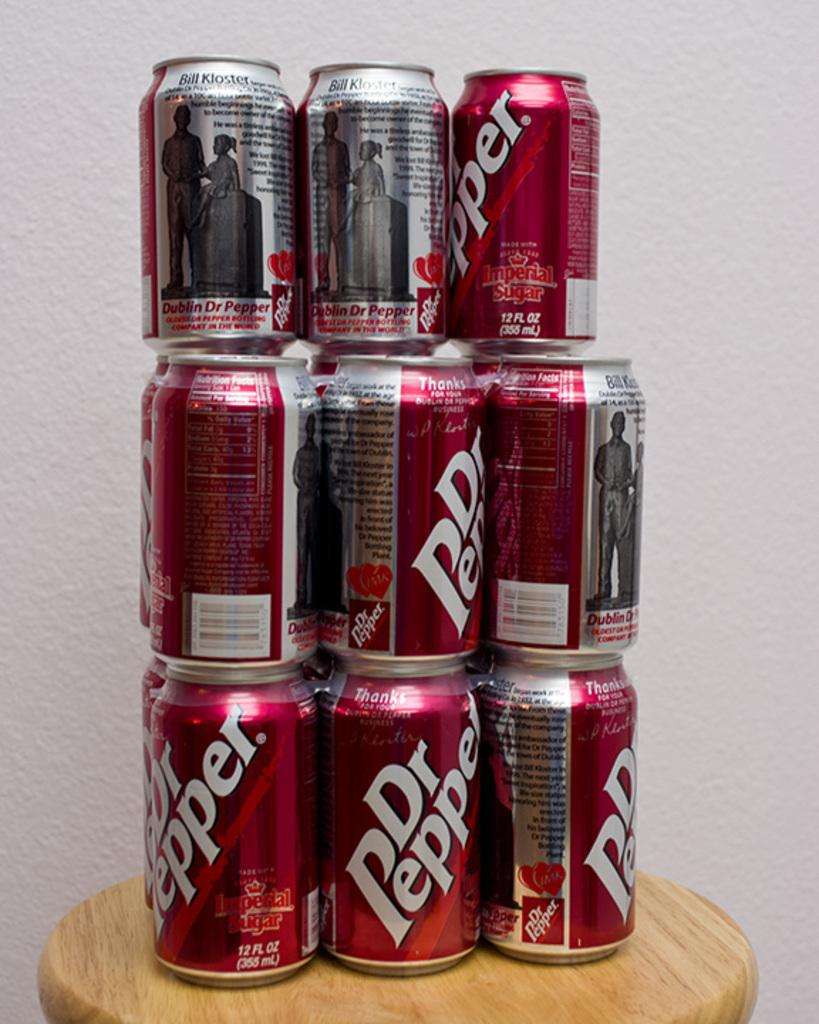<image>
Present a compact description of the photo's key features. 9 cans of doctor pepper are stacked up on a table 